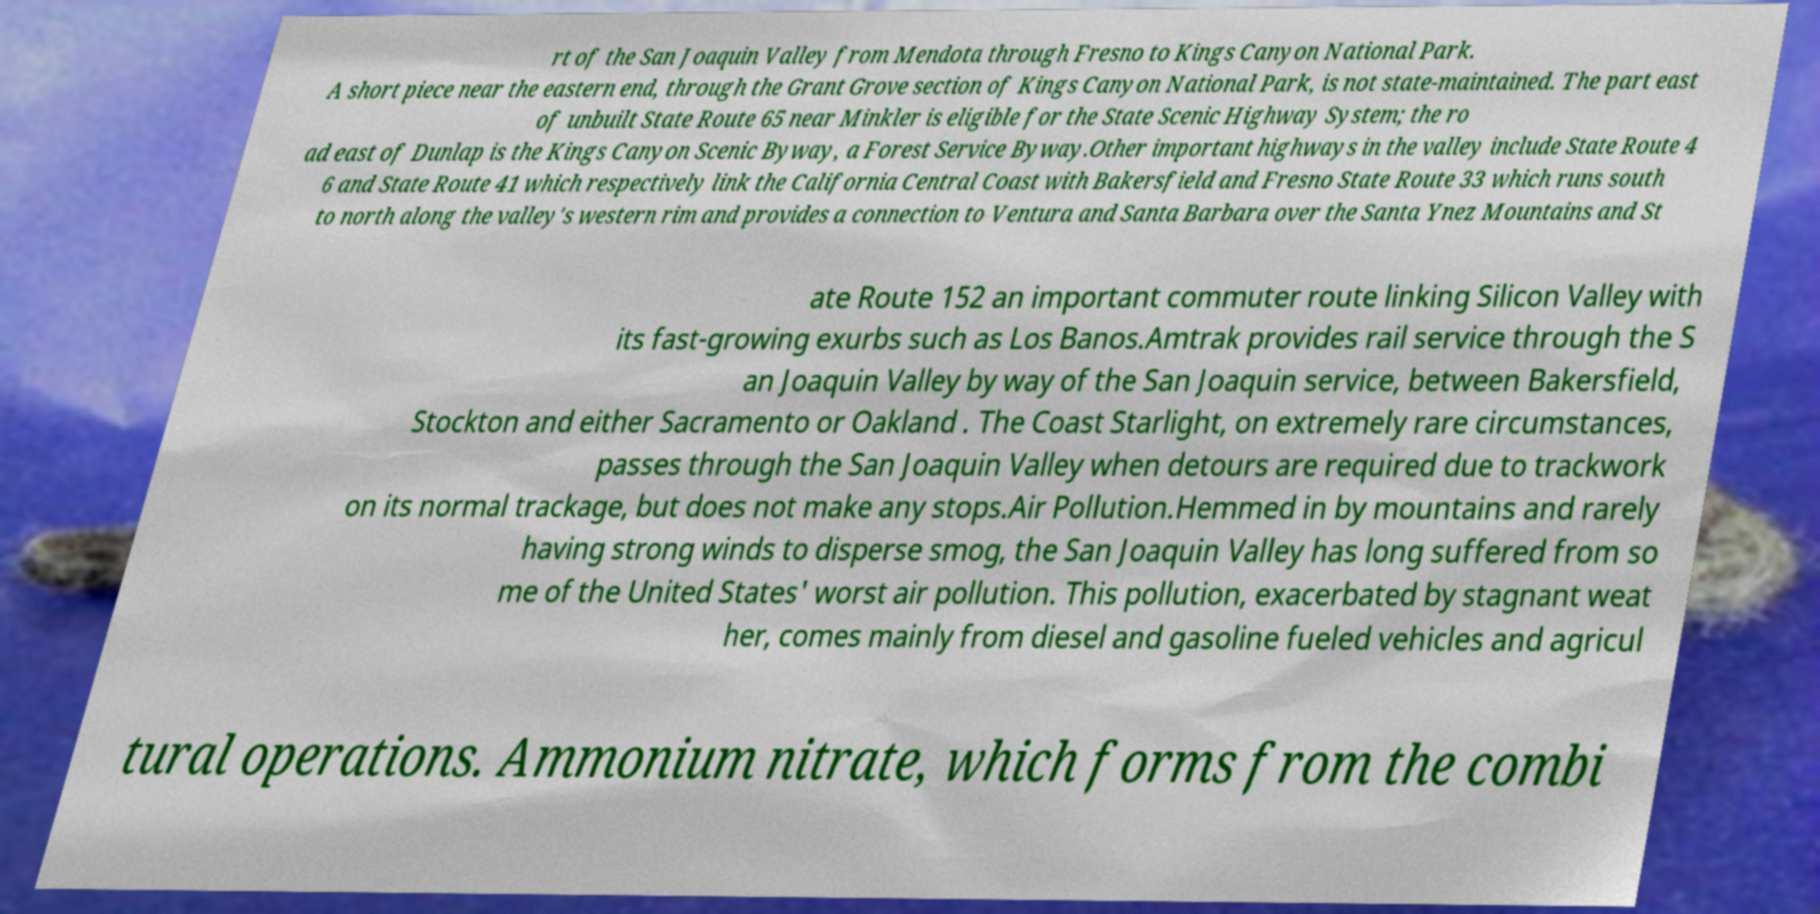For documentation purposes, I need the text within this image transcribed. Could you provide that? rt of the San Joaquin Valley from Mendota through Fresno to Kings Canyon National Park. A short piece near the eastern end, through the Grant Grove section of Kings Canyon National Park, is not state-maintained. The part east of unbuilt State Route 65 near Minkler is eligible for the State Scenic Highway System; the ro ad east of Dunlap is the Kings Canyon Scenic Byway, a Forest Service Byway.Other important highways in the valley include State Route 4 6 and State Route 41 which respectively link the California Central Coast with Bakersfield and Fresno State Route 33 which runs south to north along the valley's western rim and provides a connection to Ventura and Santa Barbara over the Santa Ynez Mountains and St ate Route 152 an important commuter route linking Silicon Valley with its fast-growing exurbs such as Los Banos.Amtrak provides rail service through the S an Joaquin Valley by way of the San Joaquin service, between Bakersfield, Stockton and either Sacramento or Oakland . The Coast Starlight, on extremely rare circumstances, passes through the San Joaquin Valley when detours are required due to trackwork on its normal trackage, but does not make any stops.Air Pollution.Hemmed in by mountains and rarely having strong winds to disperse smog, the San Joaquin Valley has long suffered from so me of the United States' worst air pollution. This pollution, exacerbated by stagnant weat her, comes mainly from diesel and gasoline fueled vehicles and agricul tural operations. Ammonium nitrate, which forms from the combi 